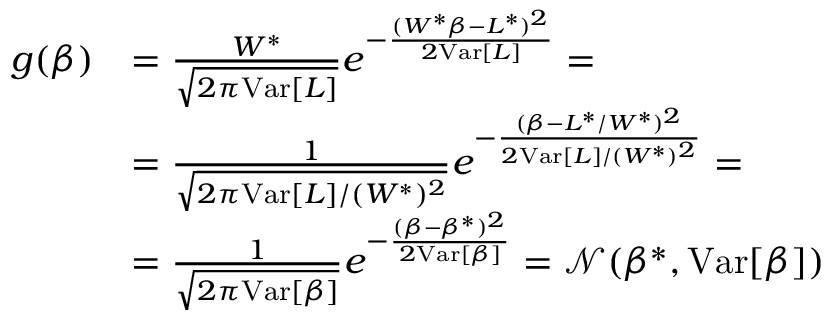Convert formula to latex. <formula><loc_0><loc_0><loc_500><loc_500>\begin{array} { r l } { g ( \beta ) } & { = \frac { W ^ { * } } { \sqrt { 2 \pi V a r [ L ] } } e ^ { - \frac { ( W ^ { * } \beta - L ^ { * } ) ^ { 2 } } { 2 V a r [ L ] } } = } \\ & { = \frac { 1 } { \sqrt { 2 \pi V a r [ L ] / ( W ^ { * } ) ^ { 2 } } } e ^ { - \frac { ( \beta - L ^ { * } / W ^ { * } ) ^ { 2 } } { 2 V a r [ L ] / ( W ^ { * } ) ^ { 2 } } } = } \\ & { = \frac { 1 } { \sqrt { 2 \pi V a r [ \beta ] } } e ^ { - \frac { ( \beta - \beta ^ { * } ) ^ { 2 } } { 2 V a r [ \beta ] } } = \mathcal { N } ( \beta ^ { * } , V a r [ \beta ] ) } \end{array}</formula> 